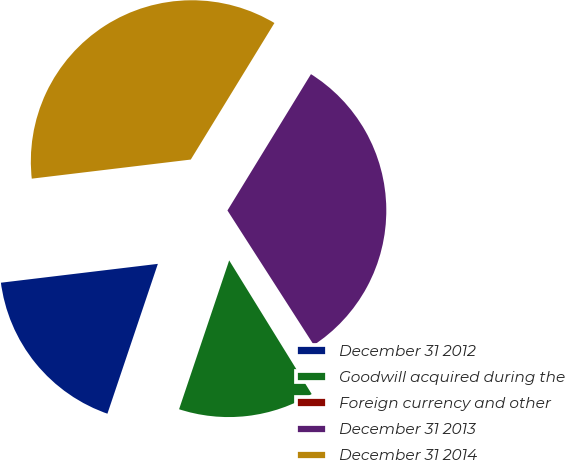Convert chart to OTSL. <chart><loc_0><loc_0><loc_500><loc_500><pie_chart><fcel>December 31 2012<fcel>Goodwill acquired during the<fcel>Foreign currency and other<fcel>December 31 2013<fcel>December 31 2014<nl><fcel>17.93%<fcel>13.97%<fcel>0.28%<fcel>32.17%<fcel>35.65%<nl></chart> 